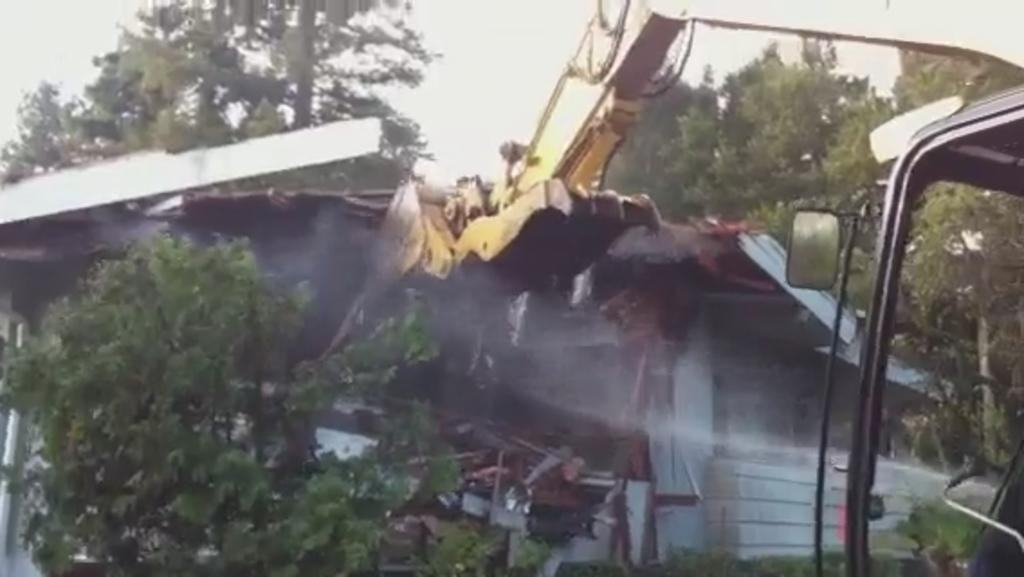What is the main subject of the image? The main subject of the image is a crane. What is the crane doing in the image? The crane is collapsing a house in the image. Can you describe the house in the image? The house is present in the image and is being collapsed by the crane. What other natural elements can be seen in the image? There are trees and plants in the image. What type of bean is growing on the crane in the image? There are no beans present in the image, and the crane is not a plant that can grow beans. 